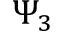Convert formula to latex. <formula><loc_0><loc_0><loc_500><loc_500>\Psi _ { 3 }</formula> 